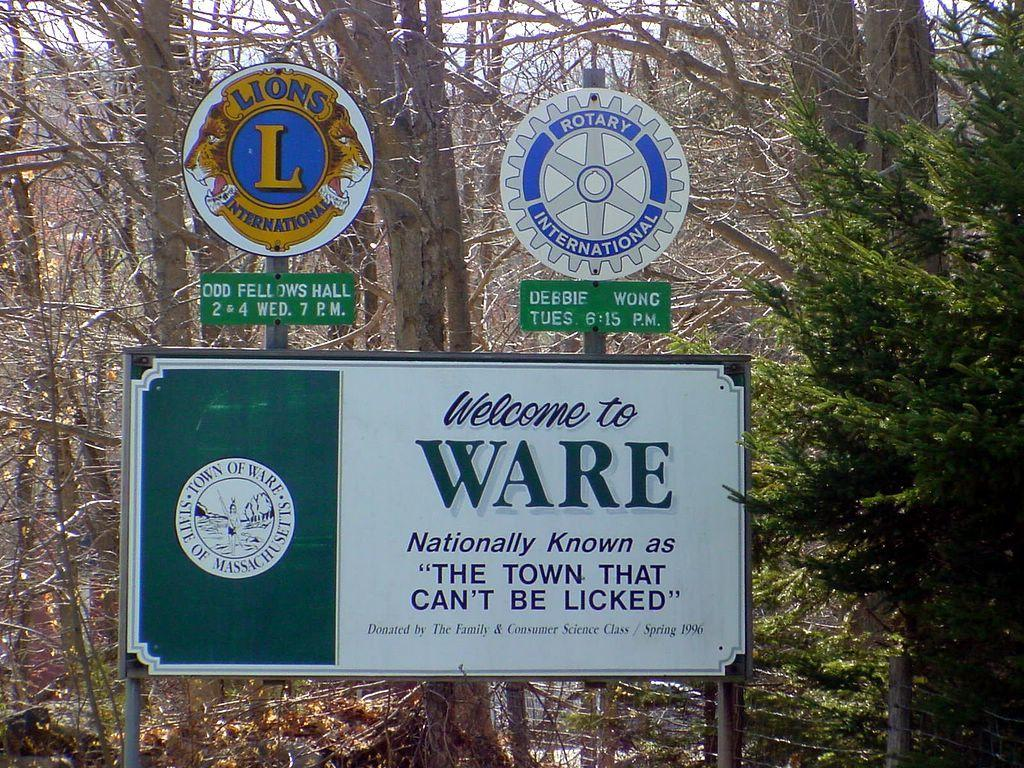<image>
Summarize the visual content of the image. the name ware that is on a sign outside 